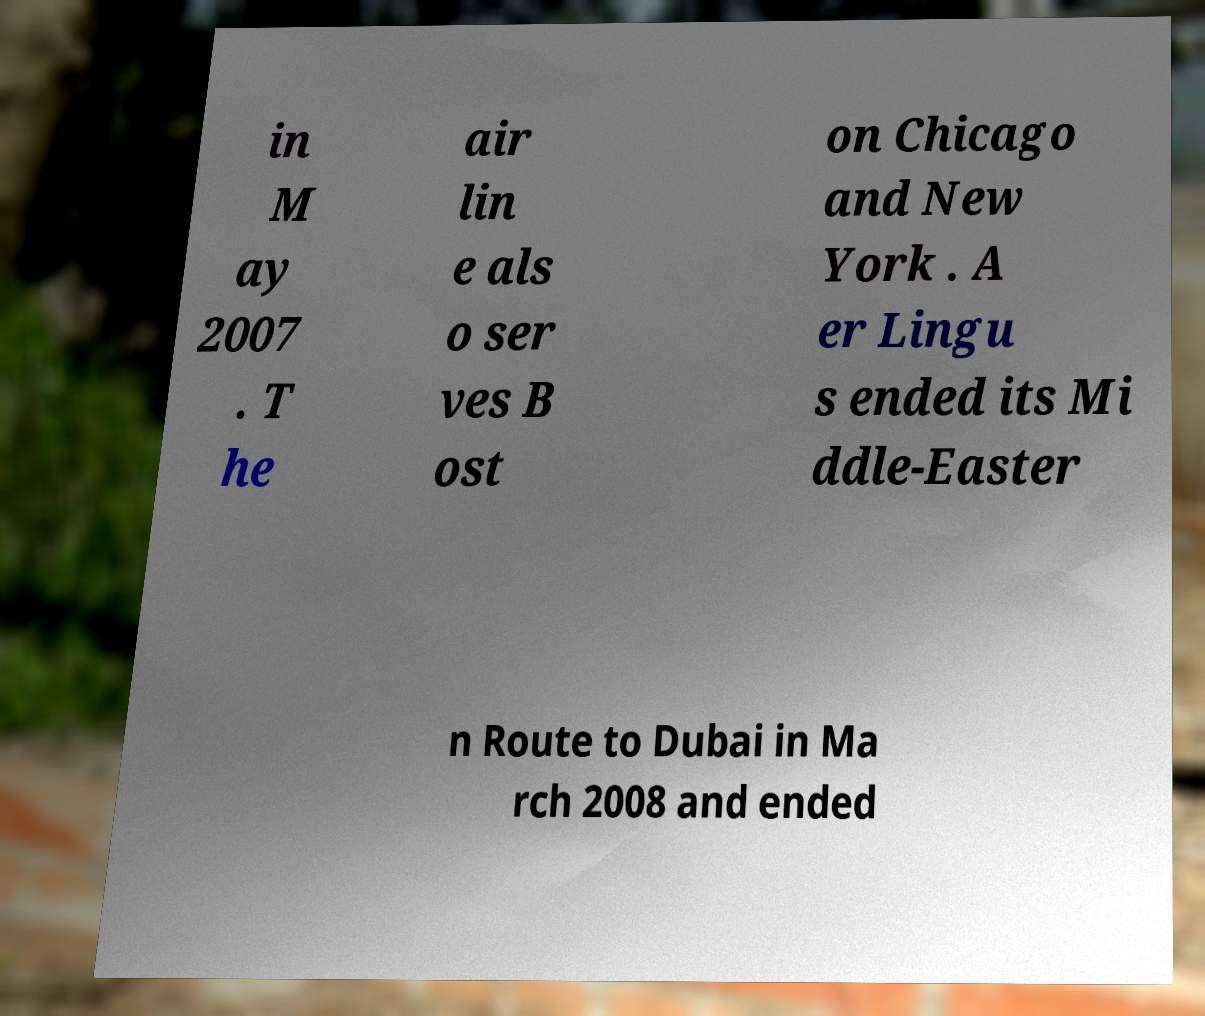Can you read and provide the text displayed in the image?This photo seems to have some interesting text. Can you extract and type it out for me? in M ay 2007 . T he air lin e als o ser ves B ost on Chicago and New York . A er Lingu s ended its Mi ddle-Easter n Route to Dubai in Ma rch 2008 and ended 